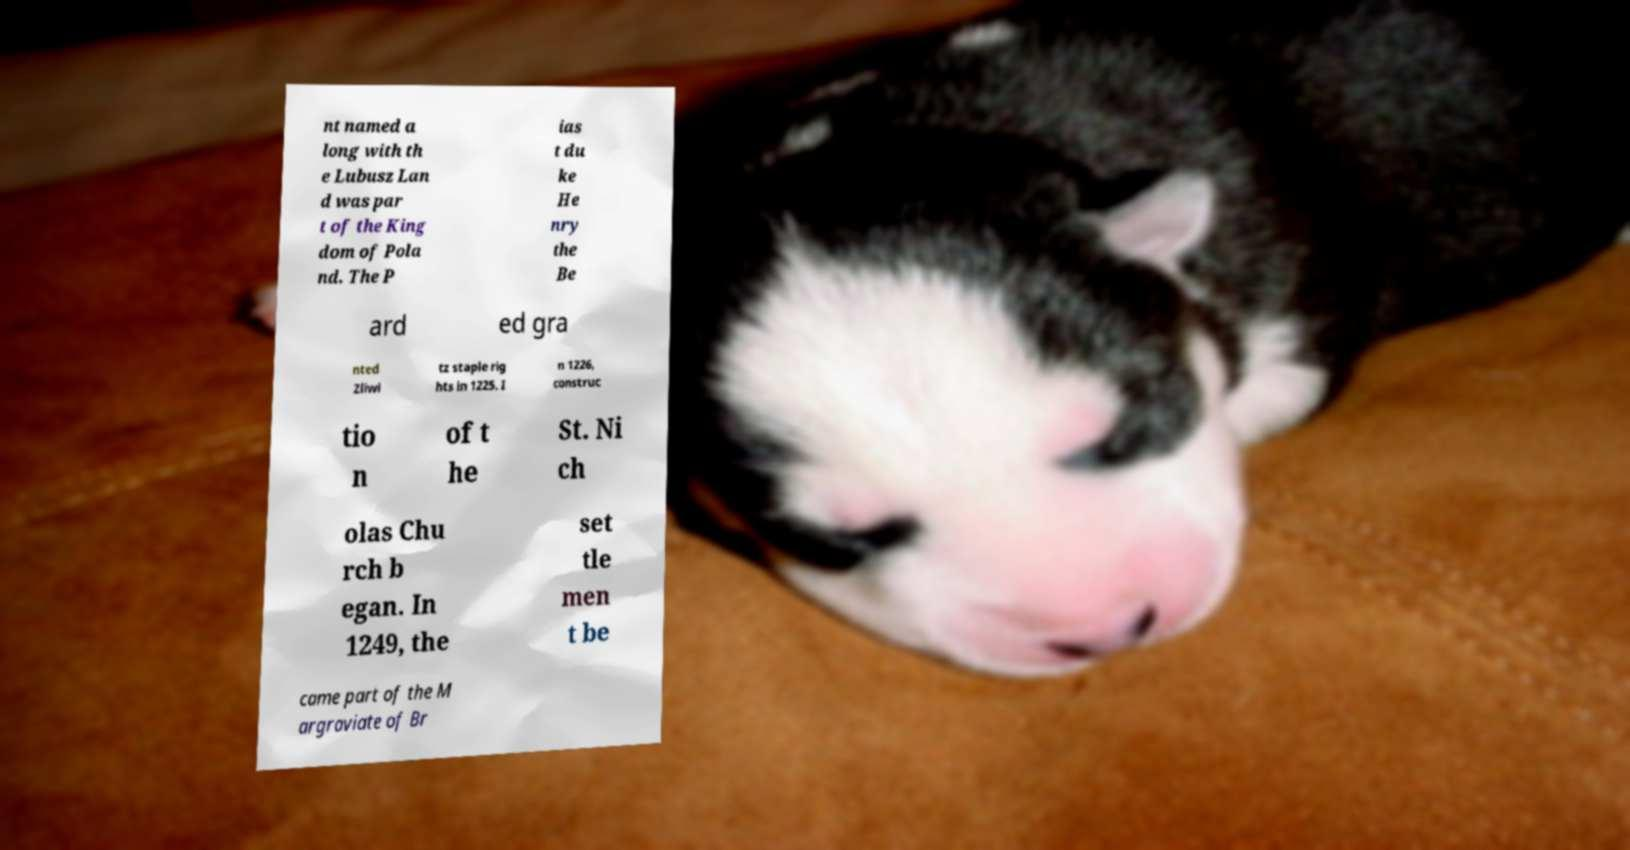Please identify and transcribe the text found in this image. nt named a long with th e Lubusz Lan d was par t of the King dom of Pola nd. The P ias t du ke He nry the Be ard ed gra nted Zliwi tz staple rig hts in 1225. I n 1226, construc tio n of t he St. Ni ch olas Chu rch b egan. In 1249, the set tle men t be came part of the M argraviate of Br 